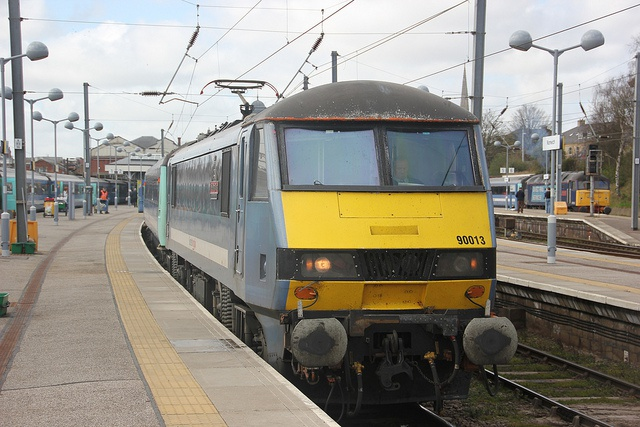Describe the objects in this image and their specific colors. I can see train in lightgray, black, gray, darkgray, and gold tones, train in lightgray, gray, darkgray, black, and olive tones, train in lightgray, gray, darkgray, teal, and black tones, people in lightgray, gray, darkgray, black, and blue tones, and people in lightgray, black, gray, and maroon tones in this image. 